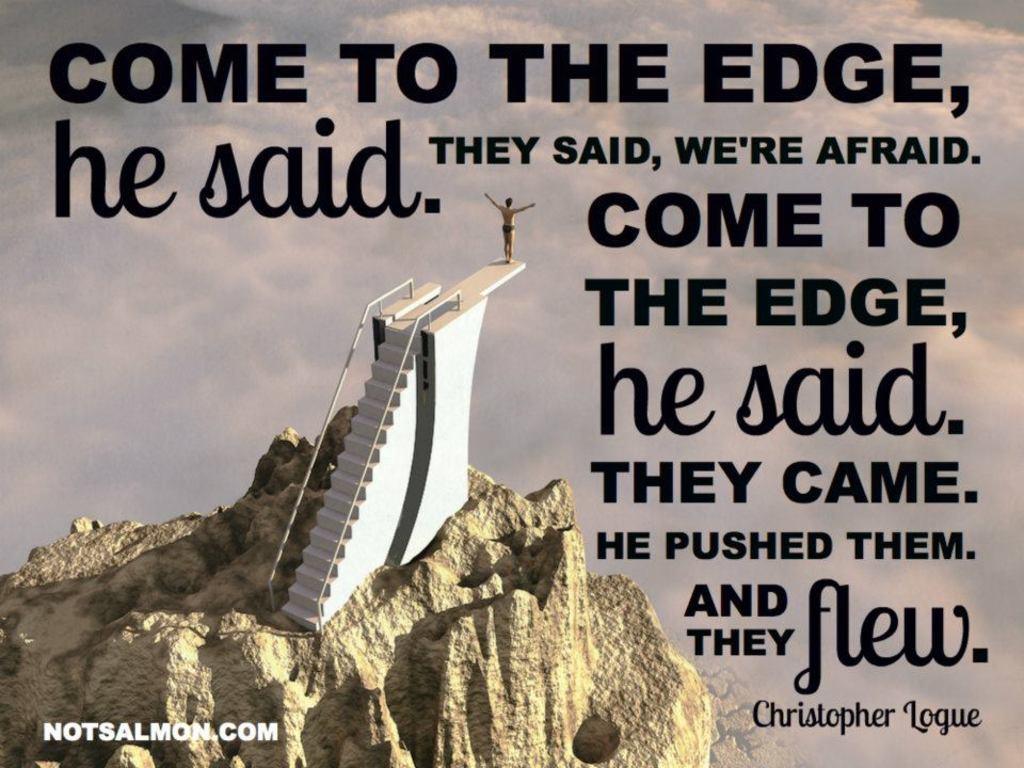<image>
Describe the image concisely. A quote by Christopher Logue on an image of a man on a diving board at the top of a mountain. 